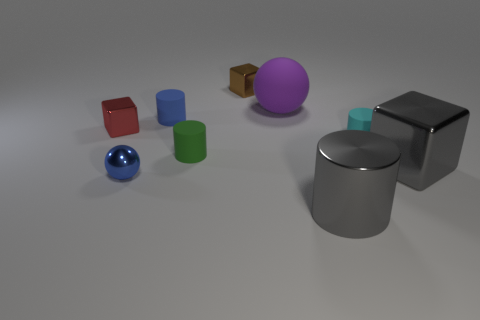How many other large rubber balls have the same color as the large matte ball?
Keep it short and to the point. 0. Does the tiny red thing that is in front of the purple matte ball have the same shape as the tiny thing that is right of the brown cube?
Offer a very short reply. No. What number of green things are to the right of the large object that is behind the matte cylinder that is right of the purple rubber sphere?
Provide a succinct answer. 0. The small cylinder that is on the right side of the cylinder that is in front of the large gray thing behind the large gray metallic cylinder is made of what material?
Ensure brevity in your answer.  Rubber. Do the small cube that is right of the tiny green thing and the green cylinder have the same material?
Give a very brief answer. No. What number of blocks are the same size as the blue metal ball?
Provide a short and direct response. 2. Are there more blue things right of the purple rubber sphere than shiny things that are behind the small cyan object?
Your answer should be compact. No. Is there another tiny brown thing that has the same shape as the tiny brown object?
Offer a terse response. No. There is a blue thing that is on the left side of the tiny blue object that is behind the green cylinder; what size is it?
Your response must be concise. Small. What is the shape of the blue thing behind the red shiny object to the left of the rubber object that is in front of the cyan thing?
Ensure brevity in your answer.  Cylinder. 